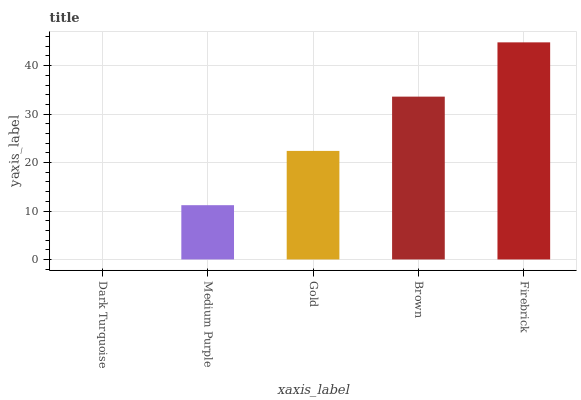Is Dark Turquoise the minimum?
Answer yes or no. Yes. Is Firebrick the maximum?
Answer yes or no. Yes. Is Medium Purple the minimum?
Answer yes or no. No. Is Medium Purple the maximum?
Answer yes or no. No. Is Medium Purple greater than Dark Turquoise?
Answer yes or no. Yes. Is Dark Turquoise less than Medium Purple?
Answer yes or no. Yes. Is Dark Turquoise greater than Medium Purple?
Answer yes or no. No. Is Medium Purple less than Dark Turquoise?
Answer yes or no. No. Is Gold the high median?
Answer yes or no. Yes. Is Gold the low median?
Answer yes or no. Yes. Is Medium Purple the high median?
Answer yes or no. No. Is Brown the low median?
Answer yes or no. No. 